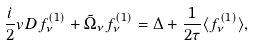<formula> <loc_0><loc_0><loc_500><loc_500>\frac { i } { 2 } { v D } f _ { \nu } ^ { ( 1 ) } + \tilde { \Omega } _ { \nu } f _ { \nu } ^ { ( 1 ) } = \Delta + \frac { 1 } { 2 \tau } \langle f _ { \nu } ^ { ( 1 ) } \rangle ,</formula> 